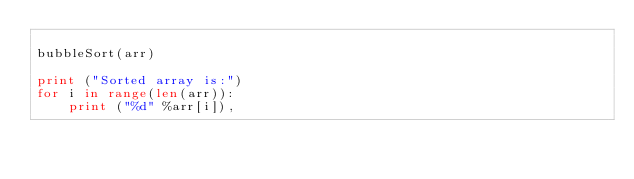<code> <loc_0><loc_0><loc_500><loc_500><_Python_>  
bubbleSort(arr) 
  
print ("Sorted array is:") 
for i in range(len(arr)): 
    print ("%d" %arr[i]), 
</code> 